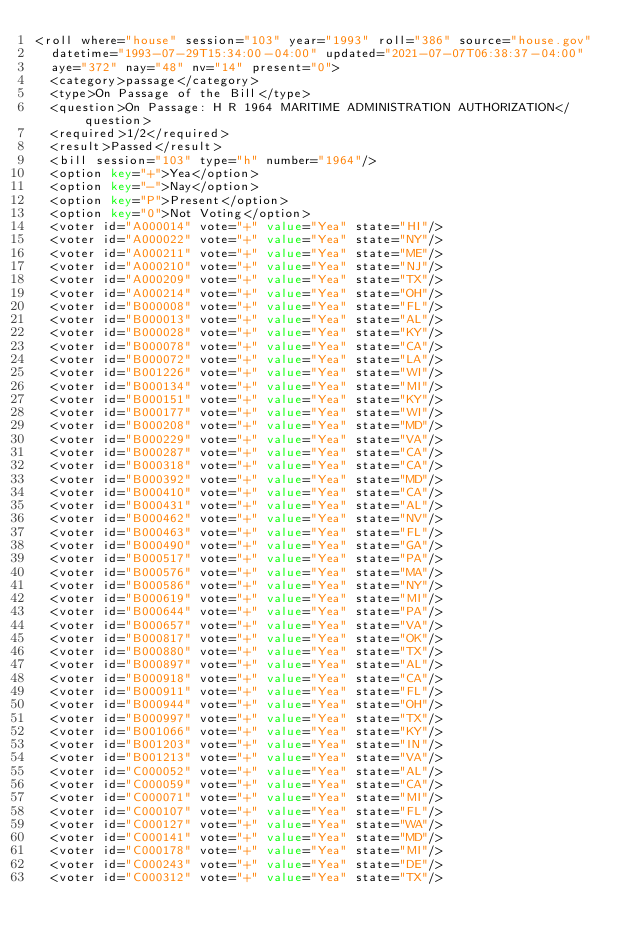Convert code to text. <code><loc_0><loc_0><loc_500><loc_500><_XML_><roll where="house" session="103" year="1993" roll="386" source="house.gov"
  datetime="1993-07-29T15:34:00-04:00" updated="2021-07-07T06:38:37-04:00"
  aye="372" nay="48" nv="14" present="0">
  <category>passage</category>
  <type>On Passage of the Bill</type>
  <question>On Passage: H R 1964 MARITIME ADMINISTRATION AUTHORIZATION</question>
  <required>1/2</required>
  <result>Passed</result>
  <bill session="103" type="h" number="1964"/>
  <option key="+">Yea</option>
  <option key="-">Nay</option>
  <option key="P">Present</option>
  <option key="0">Not Voting</option>
  <voter id="A000014" vote="+" value="Yea" state="HI"/>
  <voter id="A000022" vote="+" value="Yea" state="NY"/>
  <voter id="A000211" vote="+" value="Yea" state="ME"/>
  <voter id="A000210" vote="+" value="Yea" state="NJ"/>
  <voter id="A000209" vote="+" value="Yea" state="TX"/>
  <voter id="A000214" vote="+" value="Yea" state="OH"/>
  <voter id="B000008" vote="+" value="Yea" state="FL"/>
  <voter id="B000013" vote="+" value="Yea" state="AL"/>
  <voter id="B000028" vote="+" value="Yea" state="KY"/>
  <voter id="B000078" vote="+" value="Yea" state="CA"/>
  <voter id="B000072" vote="+" value="Yea" state="LA"/>
  <voter id="B001226" vote="+" value="Yea" state="WI"/>
  <voter id="B000134" vote="+" value="Yea" state="MI"/>
  <voter id="B000151" vote="+" value="Yea" state="KY"/>
  <voter id="B000177" vote="+" value="Yea" state="WI"/>
  <voter id="B000208" vote="+" value="Yea" state="MD"/>
  <voter id="B000229" vote="+" value="Yea" state="VA"/>
  <voter id="B000287" vote="+" value="Yea" state="CA"/>
  <voter id="B000318" vote="+" value="Yea" state="CA"/>
  <voter id="B000392" vote="+" value="Yea" state="MD"/>
  <voter id="B000410" vote="+" value="Yea" state="CA"/>
  <voter id="B000431" vote="+" value="Yea" state="AL"/>
  <voter id="B000462" vote="+" value="Yea" state="NV"/>
  <voter id="B000463" vote="+" value="Yea" state="FL"/>
  <voter id="B000490" vote="+" value="Yea" state="GA"/>
  <voter id="B000517" vote="+" value="Yea" state="PA"/>
  <voter id="B000576" vote="+" value="Yea" state="MA"/>
  <voter id="B000586" vote="+" value="Yea" state="NY"/>
  <voter id="B000619" vote="+" value="Yea" state="MI"/>
  <voter id="B000644" vote="+" value="Yea" state="PA"/>
  <voter id="B000657" vote="+" value="Yea" state="VA"/>
  <voter id="B000817" vote="+" value="Yea" state="OK"/>
  <voter id="B000880" vote="+" value="Yea" state="TX"/>
  <voter id="B000897" vote="+" value="Yea" state="AL"/>
  <voter id="B000918" vote="+" value="Yea" state="CA"/>
  <voter id="B000911" vote="+" value="Yea" state="FL"/>
  <voter id="B000944" vote="+" value="Yea" state="OH"/>
  <voter id="B000997" vote="+" value="Yea" state="TX"/>
  <voter id="B001066" vote="+" value="Yea" state="KY"/>
  <voter id="B001203" vote="+" value="Yea" state="IN"/>
  <voter id="B001213" vote="+" value="Yea" state="VA"/>
  <voter id="C000052" vote="+" value="Yea" state="AL"/>
  <voter id="C000059" vote="+" value="Yea" state="CA"/>
  <voter id="C000071" vote="+" value="Yea" state="MI"/>
  <voter id="C000107" vote="+" value="Yea" state="FL"/>
  <voter id="C000127" vote="+" value="Yea" state="WA"/>
  <voter id="C000141" vote="+" value="Yea" state="MD"/>
  <voter id="C000178" vote="+" value="Yea" state="MI"/>
  <voter id="C000243" vote="+" value="Yea" state="DE"/>
  <voter id="C000312" vote="+" value="Yea" state="TX"/></code> 